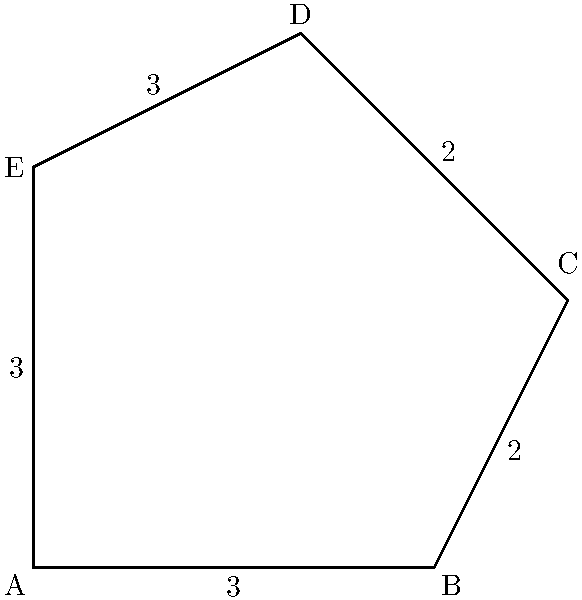Imagine the shape above represents a simplified outline of the Dominican Republic. As a loyal fan of Antony Santos, you want to calculate the area of this representation of your beloved country. Given that the shape can be divided into a rectangle and two triangles, what is the total area of this irregular polygon? Let's approach this step-by-step:

1) First, we can divide the shape into a rectangle (ABFE) and two triangles (BCE and CDE).

2) Calculate the area of rectangle ABFE:
   Length = 3, Width = 3
   Area of rectangle = $3 \times 3 = 9$ square units

3) Calculate the area of triangle BCE:
   Base = 1, Height = 2
   Area of triangle BCE = $\frac{1 \times 2}{2} = 1$ square unit

4) Calculate the area of triangle CDE:
   Base = 2, Height = 2
   Area of triangle CDE = $\frac{2 \times 2}{2} = 2$ square units

5) Sum up all areas:
   Total Area = Area of rectangle + Area of triangle BCE + Area of triangle CDE
               = $9 + 1 + 2 = 12$ square units

Therefore, the total area of this representation of the Dominican Republic is 12 square units.
Answer: 12 square units 